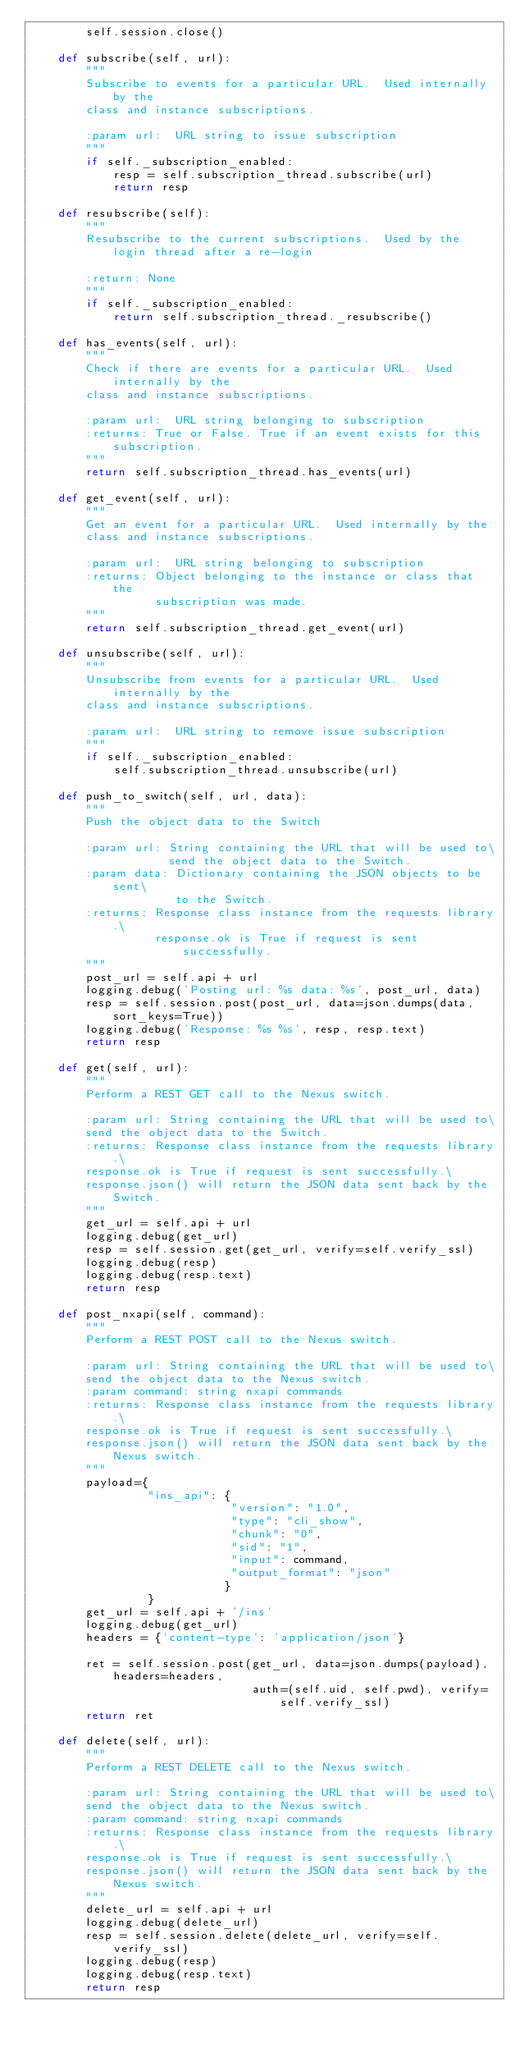Convert code to text. <code><loc_0><loc_0><loc_500><loc_500><_Python_>        self.session.close()

    def subscribe(self, url):
        """
        Subscribe to events for a particular URL.  Used internally by the
        class and instance subscriptions.

        :param url:  URL string to issue subscription
        """
        if self._subscription_enabled:
            resp = self.subscription_thread.subscribe(url)
            return resp

    def resubscribe(self):
        """
        Resubscribe to the current subscriptions.  Used by the login thread after a re-login

        :return: None
        """
        if self._subscription_enabled:
            return self.subscription_thread._resubscribe()

    def has_events(self, url):
        """
        Check if there are events for a particular URL.  Used internally by the
        class and instance subscriptions.

        :param url:  URL string belonging to subscription
        :returns: True or False. True if an event exists for this subscription.
        """
        return self.subscription_thread.has_events(url)

    def get_event(self, url):
        """
        Get an event for a particular URL.  Used internally by the
        class and instance subscriptions.

        :param url:  URL string belonging to subscription
        :returns: Object belonging to the instance or class that the
                  subscription was made.
        """
        return self.subscription_thread.get_event(url)

    def unsubscribe(self, url):
        """
        Unsubscribe from events for a particular URL.  Used internally by the
        class and instance subscriptions.

        :param url:  URL string to remove issue subscription
        """
        if self._subscription_enabled:
            self.subscription_thread.unsubscribe(url)

    def push_to_switch(self, url, data):
        """
        Push the object data to the Switch

        :param url: String containing the URL that will be used to\
                    send the object data to the Switch.
        :param data: Dictionary containing the JSON objects to be sent\
                     to the Switch.
        :returns: Response class instance from the requests library.\
                  response.ok is True if request is sent successfully.
        """
        post_url = self.api + url
        logging.debug('Posting url: %s data: %s', post_url, data)
        resp = self.session.post(post_url, data=json.dumps(data, sort_keys=True))
        logging.debug('Response: %s %s', resp, resp.text)
        return resp

    def get(self, url):
        """
        Perform a REST GET call to the Nexus switch.

        :param url: String containing the URL that will be used to\
        send the object data to the Switch.
        :returns: Response class instance from the requests library.\
        response.ok is True if request is sent successfully.\
        response.json() will return the JSON data sent back by the Switch.
        """
        get_url = self.api + url
        logging.debug(get_url)
        resp = self.session.get(get_url, verify=self.verify_ssl)
        logging.debug(resp)
        logging.debug(resp.text)
        return resp
    
    def post_nxapi(self, command):
        """
        Perform a REST POST call to the Nexus switch.

        :param url: String containing the URL that will be used to\
        send the object data to the Nexus switch.
        :param command: string nxapi commands
        :returns: Response class instance from the requests library.\
        response.ok is True if request is sent successfully.\
        response.json() will return the JSON data sent back by the Nexus switch.
        """
        payload={
                 "ins_api": {
                             "version": "1.0",
                             "type": "cli_show",
                             "chunk": "0",
                             "sid": "1",
                             "input": command,
                             "output_format": "json"
                            }
                 }
        get_url = self.api + '/ins'
        logging.debug(get_url)
        headers = {'content-type': 'application/json'}
        
        ret = self.session.post(get_url, data=json.dumps(payload), headers=headers,
                                auth=(self.uid, self.pwd), verify=self.verify_ssl)
        return ret
    
    def delete(self, url):
        """
        Perform a REST DELETE call to the Nexus switch.

        :param url: String containing the URL that will be used to\
        send the object data to the Nexus switch.
        :param command: string nxapi commands
        :returns: Response class instance from the requests library.\
        response.ok is True if request is sent successfully.\
        response.json() will return the JSON data sent back by the Nexus switch.
        """
        delete_url = self.api + url
        logging.debug(delete_url)
        resp = self.session.delete(delete_url, verify=self.verify_ssl)
        logging.debug(resp)
        logging.debug(resp.text)
        return resp
</code> 